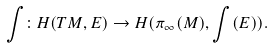<formula> <loc_0><loc_0><loc_500><loc_500>\int \colon H ( T M , E ) \to H ( \pi _ { \infty } ( M ) , \int ( E ) ) .</formula> 